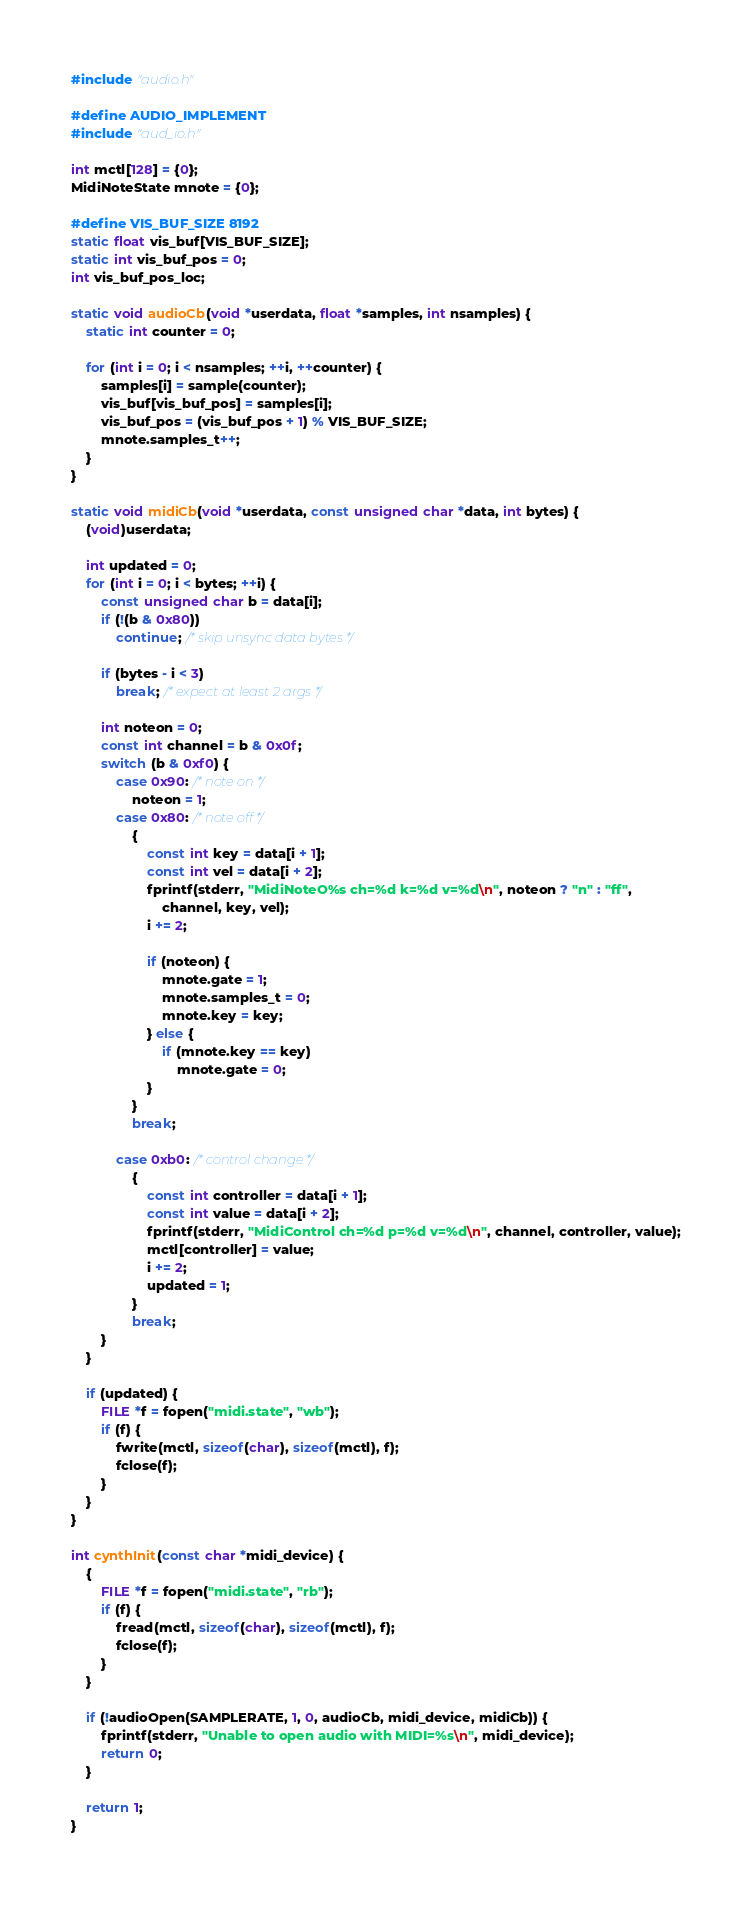<code> <loc_0><loc_0><loc_500><loc_500><_C_>#include "audio.h"

#define AUDIO_IMPLEMENT
#include "aud_io.h"

int mctl[128] = {0};
MidiNoteState mnote = {0};

#define VIS_BUF_SIZE 8192
static float vis_buf[VIS_BUF_SIZE];
static int vis_buf_pos = 0;
int vis_buf_pos_loc;

static void audioCb(void *userdata, float *samples, int nsamples) {
	static int counter = 0;

	for (int i = 0; i < nsamples; ++i, ++counter) {
		samples[i] = sample(counter);
		vis_buf[vis_buf_pos] = samples[i];
		vis_buf_pos = (vis_buf_pos + 1) % VIS_BUF_SIZE;
		mnote.samples_t++;
	}
}

static void midiCb(void *userdata, const unsigned char *data, int bytes) {
	(void)userdata;

	int updated = 0;
	for (int i = 0; i < bytes; ++i) {
		const unsigned char b = data[i];
		if (!(b & 0x80))
			continue; /* skip unsync data bytes */

		if (bytes - i < 3)
			break; /* expect at least 2 args */

		int noteon = 0;
		const int channel = b & 0x0f;
		switch (b & 0xf0) {
			case 0x90: /* note on */
				noteon = 1;
			case 0x80: /* note off */
				{
					const int key = data[i + 1];
					const int vel = data[i + 2];
					fprintf(stderr, "MidiNoteO%s ch=%d k=%d v=%d\n", noteon ? "n" : "ff",
						channel, key, vel);
					i += 2;

					if (noteon) {
						mnote.gate = 1;
						mnote.samples_t = 0;
						mnote.key = key;
					} else {
						if (mnote.key == key)
							mnote.gate = 0;
					}
				}
				break;

			case 0xb0: /* control change */
				{
					const int controller = data[i + 1];
					const int value = data[i + 2];
					fprintf(stderr, "MidiControl ch=%d p=%d v=%d\n", channel, controller, value);
					mctl[controller] = value;
					i += 2;
					updated = 1;
				}
				break;
		}
	}

	if (updated) {
		FILE *f = fopen("midi.state", "wb");
		if (f) {
			fwrite(mctl, sizeof(char), sizeof(mctl), f);
			fclose(f);
		}
	}
}

int cynthInit(const char *midi_device) {
	{
		FILE *f = fopen("midi.state", "rb");
		if (f) {
			fread(mctl, sizeof(char), sizeof(mctl), f);
			fclose(f);
		}
	}

	if (!audioOpen(SAMPLERATE, 1, 0, audioCb, midi_device, midiCb)) {
		fprintf(stderr, "Unable to open audio with MIDI=%s\n", midi_device);
		return 0;
	}

	return 1;
}
</code> 